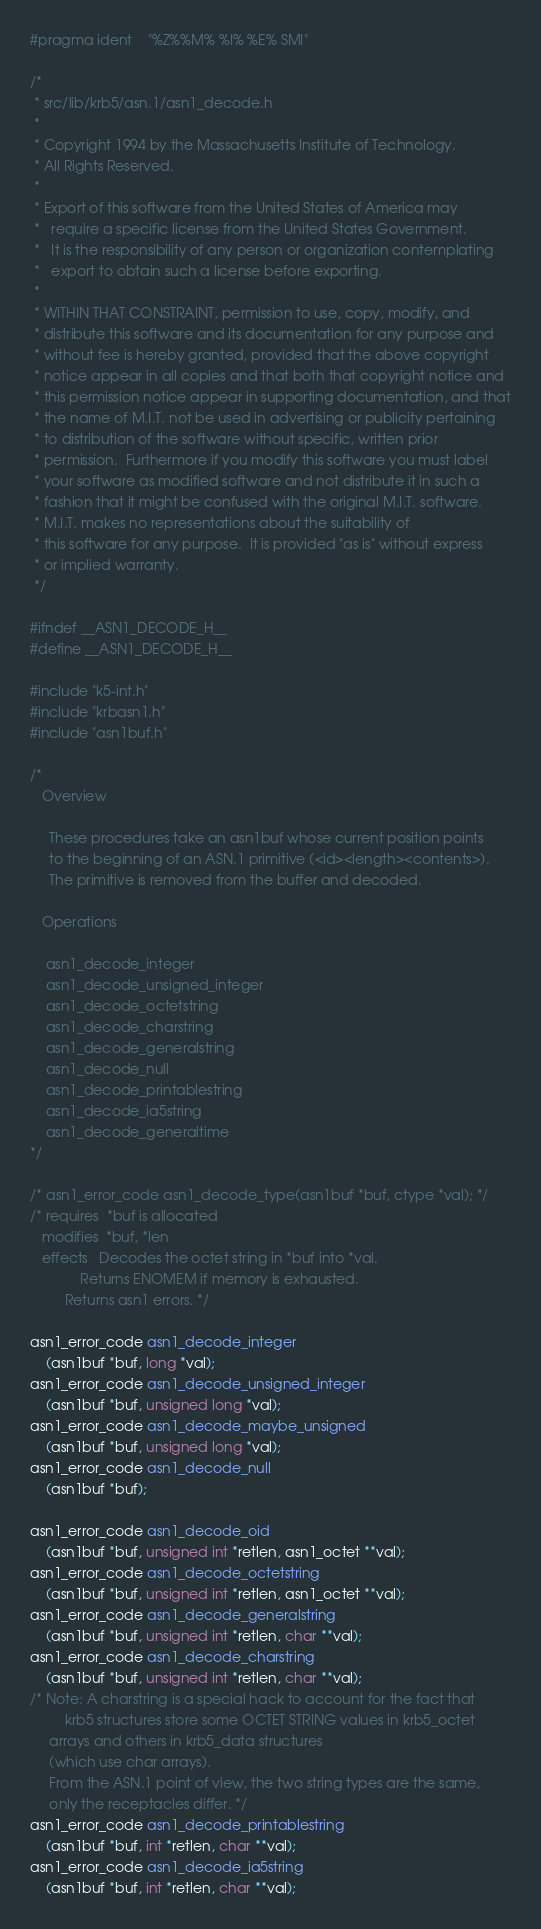<code> <loc_0><loc_0><loc_500><loc_500><_C_>#pragma ident	"%Z%%M%	%I%	%E% SMI"

/*
 * src/lib/krb5/asn.1/asn1_decode.h
 * 
 * Copyright 1994 by the Massachusetts Institute of Technology.
 * All Rights Reserved.
 *
 * Export of this software from the United States of America may
 *   require a specific license from the United States Government.
 *   It is the responsibility of any person or organization contemplating
 *   export to obtain such a license before exporting.
 * 
 * WITHIN THAT CONSTRAINT, permission to use, copy, modify, and
 * distribute this software and its documentation for any purpose and
 * without fee is hereby granted, provided that the above copyright
 * notice appear in all copies and that both that copyright notice and
 * this permission notice appear in supporting documentation, and that
 * the name of M.I.T. not be used in advertising or publicity pertaining
 * to distribution of the software without specific, written prior
 * permission.  Furthermore if you modify this software you must label
 * your software as modified software and not distribute it in such a
 * fashion that it might be confused with the original M.I.T. software.
 * M.I.T. makes no representations about the suitability of
 * this software for any purpose.  It is provided "as is" without express
 * or implied warranty.
 */

#ifndef __ASN1_DECODE_H__
#define __ASN1_DECODE_H__

#include "k5-int.h"
#include "krbasn1.h"
#include "asn1buf.h"

/*
   Overview

     These procedures take an asn1buf whose current position points
     to the beginning of an ASN.1 primitive (<id><length><contents>).
     The primitive is removed from the buffer and decoded.

   Operations

    asn1_decode_integer
    asn1_decode_unsigned_integer
    asn1_decode_octetstring
    asn1_decode_charstring
    asn1_decode_generalstring
    asn1_decode_null
    asn1_decode_printablestring
    asn1_decode_ia5string
    asn1_decode_generaltime
*/

/* asn1_error_code asn1_decode_type(asn1buf *buf, ctype *val); */
/* requires  *buf is allocated
   modifies  *buf, *len
   effects   Decodes the octet string in *buf into *val.
             Returns ENOMEM if memory is exhausted.
	     Returns asn1 errors. */

asn1_error_code asn1_decode_integer
	(asn1buf *buf, long *val);
asn1_error_code asn1_decode_unsigned_integer
	(asn1buf *buf, unsigned long *val);
asn1_error_code asn1_decode_maybe_unsigned
	(asn1buf *buf, unsigned long *val);
asn1_error_code asn1_decode_null
	(asn1buf *buf);

asn1_error_code asn1_decode_oid
	(asn1buf *buf, unsigned int *retlen, asn1_octet **val);
asn1_error_code asn1_decode_octetstring
	(asn1buf *buf, unsigned int *retlen, asn1_octet **val);
asn1_error_code asn1_decode_generalstring
	(asn1buf *buf, unsigned int *retlen, char **val);
asn1_error_code asn1_decode_charstring
	(asn1buf *buf, unsigned int *retlen, char **val);
/* Note: A charstring is a special hack to account for the fact that
         krb5 structures store some OCTET STRING values in krb5_octet
	 arrays and others in krb5_data structures 
	 (which use char arrays).
	 From the ASN.1 point of view, the two string types are the same,
	 only the receptacles differ. */
asn1_error_code asn1_decode_printablestring
	(asn1buf *buf, int *retlen, char **val);
asn1_error_code asn1_decode_ia5string
	(asn1buf *buf, int *retlen, char **val);
</code> 